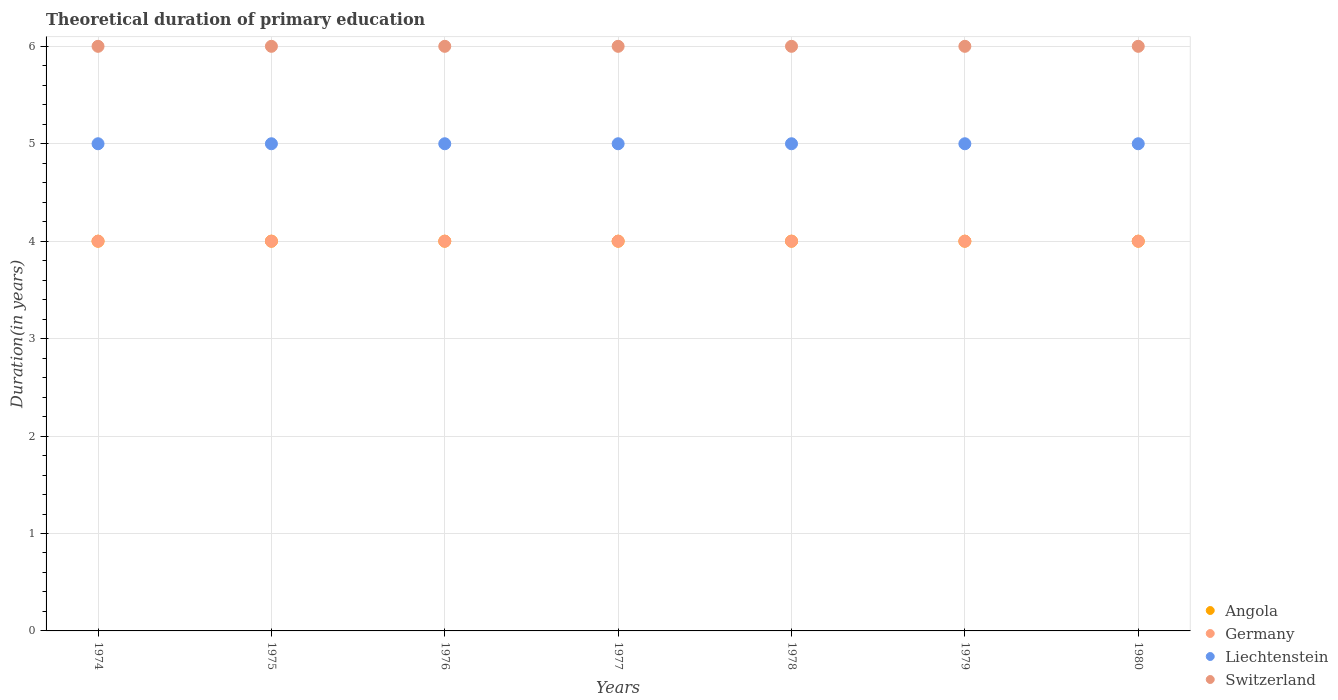Across all years, what is the maximum total theoretical duration of primary education in Liechtenstein?
Offer a very short reply. 5. Across all years, what is the minimum total theoretical duration of primary education in Switzerland?
Your response must be concise. 6. In which year was the total theoretical duration of primary education in Liechtenstein maximum?
Offer a very short reply. 1974. In which year was the total theoretical duration of primary education in Angola minimum?
Your response must be concise. 1974. What is the total total theoretical duration of primary education in Liechtenstein in the graph?
Offer a very short reply. 35. In the year 1974, what is the difference between the total theoretical duration of primary education in Germany and total theoretical duration of primary education in Liechtenstein?
Your answer should be compact. -1. What is the ratio of the total theoretical duration of primary education in Angola in 1976 to that in 1977?
Keep it short and to the point. 1. Is the total theoretical duration of primary education in Liechtenstein in 1977 less than that in 1979?
Offer a very short reply. No. Is the difference between the total theoretical duration of primary education in Germany in 1976 and 1979 greater than the difference between the total theoretical duration of primary education in Liechtenstein in 1976 and 1979?
Provide a succinct answer. No. What is the difference between the highest and the second highest total theoretical duration of primary education in Angola?
Give a very brief answer. 0. Is the sum of the total theoretical duration of primary education in Germany in 1975 and 1977 greater than the maximum total theoretical duration of primary education in Angola across all years?
Your answer should be very brief. Yes. Is it the case that in every year, the sum of the total theoretical duration of primary education in Germany and total theoretical duration of primary education in Angola  is greater than the sum of total theoretical duration of primary education in Liechtenstein and total theoretical duration of primary education in Switzerland?
Provide a short and direct response. No. Is it the case that in every year, the sum of the total theoretical duration of primary education in Angola and total theoretical duration of primary education in Switzerland  is greater than the total theoretical duration of primary education in Liechtenstein?
Your response must be concise. Yes. Is the total theoretical duration of primary education in Angola strictly greater than the total theoretical duration of primary education in Liechtenstein over the years?
Keep it short and to the point. No. How many years are there in the graph?
Provide a succinct answer. 7. What is the difference between two consecutive major ticks on the Y-axis?
Provide a succinct answer. 1. Are the values on the major ticks of Y-axis written in scientific E-notation?
Provide a succinct answer. No. Where does the legend appear in the graph?
Your answer should be compact. Bottom right. How many legend labels are there?
Offer a very short reply. 4. How are the legend labels stacked?
Keep it short and to the point. Vertical. What is the title of the graph?
Keep it short and to the point. Theoretical duration of primary education. What is the label or title of the Y-axis?
Give a very brief answer. Duration(in years). What is the Duration(in years) in Angola in 1974?
Ensure brevity in your answer.  4. What is the Duration(in years) of Germany in 1974?
Offer a terse response. 4. What is the Duration(in years) in Liechtenstein in 1974?
Your answer should be compact. 5. What is the Duration(in years) of Switzerland in 1974?
Your answer should be very brief. 6. What is the Duration(in years) of Germany in 1975?
Your response must be concise. 4. What is the Duration(in years) of Liechtenstein in 1975?
Your answer should be very brief. 5. What is the Duration(in years) in Switzerland in 1975?
Provide a short and direct response. 6. What is the Duration(in years) in Germany in 1976?
Provide a short and direct response. 4. What is the Duration(in years) in Switzerland in 1976?
Keep it short and to the point. 6. What is the Duration(in years) of Angola in 1977?
Your answer should be compact. 4. What is the Duration(in years) in Germany in 1977?
Your answer should be compact. 4. What is the Duration(in years) of Liechtenstein in 1977?
Keep it short and to the point. 5. What is the Duration(in years) in Angola in 1978?
Give a very brief answer. 4. What is the Duration(in years) in Switzerland in 1978?
Your answer should be compact. 6. What is the Duration(in years) in Switzerland in 1980?
Make the answer very short. 6. Across all years, what is the maximum Duration(in years) of Angola?
Your answer should be compact. 4. Across all years, what is the maximum Duration(in years) in Liechtenstein?
Offer a very short reply. 5. Across all years, what is the maximum Duration(in years) in Switzerland?
Keep it short and to the point. 6. Across all years, what is the minimum Duration(in years) of Angola?
Your answer should be compact. 4. Across all years, what is the minimum Duration(in years) in Switzerland?
Provide a short and direct response. 6. What is the total Duration(in years) of Angola in the graph?
Provide a succinct answer. 28. What is the total Duration(in years) of Liechtenstein in the graph?
Make the answer very short. 35. What is the difference between the Duration(in years) in Switzerland in 1974 and that in 1975?
Your answer should be compact. 0. What is the difference between the Duration(in years) of Liechtenstein in 1974 and that in 1976?
Keep it short and to the point. 0. What is the difference between the Duration(in years) in Angola in 1974 and that in 1978?
Offer a very short reply. 0. What is the difference between the Duration(in years) in Germany in 1974 and that in 1978?
Your answer should be very brief. 0. What is the difference between the Duration(in years) of Liechtenstein in 1974 and that in 1978?
Provide a short and direct response. 0. What is the difference between the Duration(in years) of Switzerland in 1974 and that in 1978?
Your answer should be very brief. 0. What is the difference between the Duration(in years) in Angola in 1974 and that in 1979?
Your answer should be very brief. 0. What is the difference between the Duration(in years) of Germany in 1974 and that in 1980?
Provide a short and direct response. 0. What is the difference between the Duration(in years) of Liechtenstein in 1974 and that in 1980?
Keep it short and to the point. 0. What is the difference between the Duration(in years) in Switzerland in 1974 and that in 1980?
Your answer should be very brief. 0. What is the difference between the Duration(in years) in Liechtenstein in 1975 and that in 1976?
Give a very brief answer. 0. What is the difference between the Duration(in years) of Switzerland in 1975 and that in 1976?
Your answer should be compact. 0. What is the difference between the Duration(in years) of Switzerland in 1975 and that in 1977?
Offer a very short reply. 0. What is the difference between the Duration(in years) of Angola in 1975 and that in 1978?
Offer a terse response. 0. What is the difference between the Duration(in years) in Germany in 1975 and that in 1979?
Offer a very short reply. 0. What is the difference between the Duration(in years) in Angola in 1975 and that in 1980?
Offer a very short reply. 0. What is the difference between the Duration(in years) of Germany in 1975 and that in 1980?
Your response must be concise. 0. What is the difference between the Duration(in years) of Switzerland in 1975 and that in 1980?
Provide a succinct answer. 0. What is the difference between the Duration(in years) in Germany in 1976 and that in 1977?
Offer a terse response. 0. What is the difference between the Duration(in years) in Liechtenstein in 1976 and that in 1977?
Make the answer very short. 0. What is the difference between the Duration(in years) of Angola in 1976 and that in 1978?
Provide a short and direct response. 0. What is the difference between the Duration(in years) of Germany in 1976 and that in 1978?
Keep it short and to the point. 0. What is the difference between the Duration(in years) in Liechtenstein in 1976 and that in 1978?
Your answer should be very brief. 0. What is the difference between the Duration(in years) in Switzerland in 1976 and that in 1978?
Your answer should be very brief. 0. What is the difference between the Duration(in years) of Angola in 1976 and that in 1979?
Your answer should be very brief. 0. What is the difference between the Duration(in years) of Germany in 1976 and that in 1979?
Offer a very short reply. 0. What is the difference between the Duration(in years) of Liechtenstein in 1976 and that in 1979?
Offer a terse response. 0. What is the difference between the Duration(in years) of Switzerland in 1976 and that in 1979?
Keep it short and to the point. 0. What is the difference between the Duration(in years) in Angola in 1977 and that in 1978?
Provide a short and direct response. 0. What is the difference between the Duration(in years) of Germany in 1977 and that in 1978?
Provide a short and direct response. 0. What is the difference between the Duration(in years) in Liechtenstein in 1977 and that in 1978?
Give a very brief answer. 0. What is the difference between the Duration(in years) in Switzerland in 1977 and that in 1978?
Your answer should be compact. 0. What is the difference between the Duration(in years) in Angola in 1977 and that in 1979?
Provide a short and direct response. 0. What is the difference between the Duration(in years) of Germany in 1977 and that in 1979?
Give a very brief answer. 0. What is the difference between the Duration(in years) of Liechtenstein in 1977 and that in 1979?
Make the answer very short. 0. What is the difference between the Duration(in years) of Switzerland in 1977 and that in 1979?
Your answer should be very brief. 0. What is the difference between the Duration(in years) of Switzerland in 1977 and that in 1980?
Make the answer very short. 0. What is the difference between the Duration(in years) in Germany in 1978 and that in 1979?
Provide a short and direct response. 0. What is the difference between the Duration(in years) of Switzerland in 1978 and that in 1979?
Your response must be concise. 0. What is the difference between the Duration(in years) in Germany in 1978 and that in 1980?
Keep it short and to the point. 0. What is the difference between the Duration(in years) in Liechtenstein in 1978 and that in 1980?
Ensure brevity in your answer.  0. What is the difference between the Duration(in years) in Angola in 1979 and that in 1980?
Your answer should be very brief. 0. What is the difference between the Duration(in years) of Liechtenstein in 1979 and that in 1980?
Provide a short and direct response. 0. What is the difference between the Duration(in years) in Angola in 1974 and the Duration(in years) in Switzerland in 1975?
Ensure brevity in your answer.  -2. What is the difference between the Duration(in years) of Angola in 1974 and the Duration(in years) of Germany in 1976?
Your response must be concise. 0. What is the difference between the Duration(in years) in Angola in 1974 and the Duration(in years) in Liechtenstein in 1976?
Ensure brevity in your answer.  -1. What is the difference between the Duration(in years) in Germany in 1974 and the Duration(in years) in Liechtenstein in 1976?
Keep it short and to the point. -1. What is the difference between the Duration(in years) in Germany in 1974 and the Duration(in years) in Switzerland in 1976?
Your answer should be compact. -2. What is the difference between the Duration(in years) of Angola in 1974 and the Duration(in years) of Germany in 1977?
Keep it short and to the point. 0. What is the difference between the Duration(in years) in Angola in 1974 and the Duration(in years) in Liechtenstein in 1977?
Provide a succinct answer. -1. What is the difference between the Duration(in years) of Germany in 1974 and the Duration(in years) of Liechtenstein in 1977?
Offer a terse response. -1. What is the difference between the Duration(in years) of Germany in 1974 and the Duration(in years) of Switzerland in 1977?
Offer a very short reply. -2. What is the difference between the Duration(in years) in Angola in 1974 and the Duration(in years) in Germany in 1978?
Provide a succinct answer. 0. What is the difference between the Duration(in years) in Germany in 1974 and the Duration(in years) in Liechtenstein in 1978?
Offer a terse response. -1. What is the difference between the Duration(in years) of Liechtenstein in 1974 and the Duration(in years) of Switzerland in 1978?
Ensure brevity in your answer.  -1. What is the difference between the Duration(in years) of Angola in 1974 and the Duration(in years) of Liechtenstein in 1979?
Offer a very short reply. -1. What is the difference between the Duration(in years) of Germany in 1974 and the Duration(in years) of Liechtenstein in 1979?
Offer a very short reply. -1. What is the difference between the Duration(in years) of Germany in 1974 and the Duration(in years) of Switzerland in 1979?
Make the answer very short. -2. What is the difference between the Duration(in years) of Angola in 1974 and the Duration(in years) of Germany in 1980?
Make the answer very short. 0. What is the difference between the Duration(in years) of Germany in 1974 and the Duration(in years) of Switzerland in 1980?
Make the answer very short. -2. What is the difference between the Duration(in years) in Angola in 1975 and the Duration(in years) in Switzerland in 1976?
Make the answer very short. -2. What is the difference between the Duration(in years) in Germany in 1975 and the Duration(in years) in Liechtenstein in 1976?
Provide a short and direct response. -1. What is the difference between the Duration(in years) of Germany in 1975 and the Duration(in years) of Switzerland in 1976?
Your response must be concise. -2. What is the difference between the Duration(in years) of Angola in 1975 and the Duration(in years) of Liechtenstein in 1977?
Ensure brevity in your answer.  -1. What is the difference between the Duration(in years) in Angola in 1975 and the Duration(in years) in Switzerland in 1977?
Your response must be concise. -2. What is the difference between the Duration(in years) in Germany in 1975 and the Duration(in years) in Liechtenstein in 1977?
Your answer should be very brief. -1. What is the difference between the Duration(in years) in Angola in 1975 and the Duration(in years) in Switzerland in 1978?
Your answer should be very brief. -2. What is the difference between the Duration(in years) in Germany in 1975 and the Duration(in years) in Liechtenstein in 1978?
Your response must be concise. -1. What is the difference between the Duration(in years) in Liechtenstein in 1975 and the Duration(in years) in Switzerland in 1978?
Give a very brief answer. -1. What is the difference between the Duration(in years) of Angola in 1975 and the Duration(in years) of Germany in 1979?
Offer a terse response. 0. What is the difference between the Duration(in years) in Angola in 1975 and the Duration(in years) in Liechtenstein in 1979?
Provide a short and direct response. -1. What is the difference between the Duration(in years) in Angola in 1975 and the Duration(in years) in Switzerland in 1979?
Offer a very short reply. -2. What is the difference between the Duration(in years) of Germany in 1975 and the Duration(in years) of Switzerland in 1979?
Offer a terse response. -2. What is the difference between the Duration(in years) in Angola in 1975 and the Duration(in years) in Germany in 1980?
Keep it short and to the point. 0. What is the difference between the Duration(in years) in Angola in 1975 and the Duration(in years) in Switzerland in 1980?
Offer a terse response. -2. What is the difference between the Duration(in years) of Liechtenstein in 1975 and the Duration(in years) of Switzerland in 1980?
Keep it short and to the point. -1. What is the difference between the Duration(in years) in Angola in 1976 and the Duration(in years) in Switzerland in 1977?
Keep it short and to the point. -2. What is the difference between the Duration(in years) of Germany in 1976 and the Duration(in years) of Liechtenstein in 1977?
Provide a succinct answer. -1. What is the difference between the Duration(in years) of Angola in 1976 and the Duration(in years) of Liechtenstein in 1978?
Offer a terse response. -1. What is the difference between the Duration(in years) in Germany in 1976 and the Duration(in years) in Switzerland in 1978?
Provide a short and direct response. -2. What is the difference between the Duration(in years) in Liechtenstein in 1976 and the Duration(in years) in Switzerland in 1978?
Your answer should be very brief. -1. What is the difference between the Duration(in years) of Angola in 1976 and the Duration(in years) of Germany in 1979?
Keep it short and to the point. 0. What is the difference between the Duration(in years) in Angola in 1976 and the Duration(in years) in Liechtenstein in 1979?
Provide a short and direct response. -1. What is the difference between the Duration(in years) in Germany in 1976 and the Duration(in years) in Liechtenstein in 1979?
Provide a short and direct response. -1. What is the difference between the Duration(in years) in Germany in 1976 and the Duration(in years) in Switzerland in 1979?
Your answer should be compact. -2. What is the difference between the Duration(in years) in Angola in 1976 and the Duration(in years) in Liechtenstein in 1980?
Give a very brief answer. -1. What is the difference between the Duration(in years) in Germany in 1976 and the Duration(in years) in Switzerland in 1980?
Offer a terse response. -2. What is the difference between the Duration(in years) in Angola in 1977 and the Duration(in years) in Switzerland in 1978?
Ensure brevity in your answer.  -2. What is the difference between the Duration(in years) of Germany in 1977 and the Duration(in years) of Liechtenstein in 1978?
Your answer should be compact. -1. What is the difference between the Duration(in years) of Germany in 1977 and the Duration(in years) of Switzerland in 1978?
Provide a short and direct response. -2. What is the difference between the Duration(in years) of Angola in 1977 and the Duration(in years) of Liechtenstein in 1979?
Your answer should be compact. -1. What is the difference between the Duration(in years) of Germany in 1977 and the Duration(in years) of Liechtenstein in 1979?
Keep it short and to the point. -1. What is the difference between the Duration(in years) in Liechtenstein in 1977 and the Duration(in years) in Switzerland in 1979?
Your answer should be compact. -1. What is the difference between the Duration(in years) of Angola in 1978 and the Duration(in years) of Liechtenstein in 1979?
Offer a very short reply. -1. What is the difference between the Duration(in years) in Angola in 1978 and the Duration(in years) in Switzerland in 1979?
Give a very brief answer. -2. What is the difference between the Duration(in years) of Germany in 1978 and the Duration(in years) of Liechtenstein in 1979?
Make the answer very short. -1. What is the difference between the Duration(in years) of Liechtenstein in 1978 and the Duration(in years) of Switzerland in 1979?
Ensure brevity in your answer.  -1. What is the difference between the Duration(in years) of Angola in 1978 and the Duration(in years) of Switzerland in 1980?
Offer a very short reply. -2. What is the difference between the Duration(in years) of Germany in 1978 and the Duration(in years) of Liechtenstein in 1980?
Offer a very short reply. -1. What is the difference between the Duration(in years) in Germany in 1978 and the Duration(in years) in Switzerland in 1980?
Offer a terse response. -2. What is the difference between the Duration(in years) in Angola in 1979 and the Duration(in years) in Germany in 1980?
Provide a short and direct response. 0. What is the difference between the Duration(in years) in Angola in 1979 and the Duration(in years) in Liechtenstein in 1980?
Provide a succinct answer. -1. What is the difference between the Duration(in years) in Germany in 1979 and the Duration(in years) in Switzerland in 1980?
Provide a short and direct response. -2. What is the difference between the Duration(in years) in Liechtenstein in 1979 and the Duration(in years) in Switzerland in 1980?
Keep it short and to the point. -1. What is the average Duration(in years) of Germany per year?
Provide a succinct answer. 4. What is the average Duration(in years) in Switzerland per year?
Make the answer very short. 6. In the year 1974, what is the difference between the Duration(in years) of Angola and Duration(in years) of Liechtenstein?
Offer a terse response. -1. In the year 1974, what is the difference between the Duration(in years) of Germany and Duration(in years) of Liechtenstein?
Offer a terse response. -1. In the year 1974, what is the difference between the Duration(in years) in Germany and Duration(in years) in Switzerland?
Make the answer very short. -2. In the year 1974, what is the difference between the Duration(in years) in Liechtenstein and Duration(in years) in Switzerland?
Offer a very short reply. -1. In the year 1975, what is the difference between the Duration(in years) of Angola and Duration(in years) of Germany?
Ensure brevity in your answer.  0. In the year 1975, what is the difference between the Duration(in years) in Germany and Duration(in years) in Liechtenstein?
Give a very brief answer. -1. In the year 1975, what is the difference between the Duration(in years) in Germany and Duration(in years) in Switzerland?
Ensure brevity in your answer.  -2. In the year 1976, what is the difference between the Duration(in years) of Angola and Duration(in years) of Liechtenstein?
Provide a short and direct response. -1. In the year 1976, what is the difference between the Duration(in years) of Germany and Duration(in years) of Switzerland?
Provide a short and direct response. -2. In the year 1976, what is the difference between the Duration(in years) in Liechtenstein and Duration(in years) in Switzerland?
Offer a terse response. -1. In the year 1977, what is the difference between the Duration(in years) in Germany and Duration(in years) in Liechtenstein?
Your response must be concise. -1. In the year 1978, what is the difference between the Duration(in years) of Angola and Duration(in years) of Liechtenstein?
Provide a succinct answer. -1. In the year 1978, what is the difference between the Duration(in years) in Germany and Duration(in years) in Liechtenstein?
Your answer should be compact. -1. In the year 1978, what is the difference between the Duration(in years) of Liechtenstein and Duration(in years) of Switzerland?
Offer a very short reply. -1. In the year 1979, what is the difference between the Duration(in years) of Angola and Duration(in years) of Germany?
Keep it short and to the point. 0. In the year 1979, what is the difference between the Duration(in years) in Angola and Duration(in years) in Liechtenstein?
Your answer should be compact. -1. In the year 1979, what is the difference between the Duration(in years) in Liechtenstein and Duration(in years) in Switzerland?
Give a very brief answer. -1. In the year 1980, what is the difference between the Duration(in years) of Angola and Duration(in years) of Germany?
Your answer should be very brief. 0. In the year 1980, what is the difference between the Duration(in years) of Angola and Duration(in years) of Liechtenstein?
Keep it short and to the point. -1. In the year 1980, what is the difference between the Duration(in years) in Angola and Duration(in years) in Switzerland?
Provide a succinct answer. -2. What is the ratio of the Duration(in years) of Angola in 1974 to that in 1975?
Provide a short and direct response. 1. What is the ratio of the Duration(in years) of Germany in 1974 to that in 1975?
Provide a short and direct response. 1. What is the ratio of the Duration(in years) of Switzerland in 1974 to that in 1975?
Keep it short and to the point. 1. What is the ratio of the Duration(in years) of Angola in 1974 to that in 1976?
Your response must be concise. 1. What is the ratio of the Duration(in years) in Liechtenstein in 1974 to that in 1976?
Provide a short and direct response. 1. What is the ratio of the Duration(in years) of Switzerland in 1974 to that in 1976?
Offer a terse response. 1. What is the ratio of the Duration(in years) in Liechtenstein in 1974 to that in 1977?
Keep it short and to the point. 1. What is the ratio of the Duration(in years) in Switzerland in 1974 to that in 1977?
Offer a terse response. 1. What is the ratio of the Duration(in years) of Germany in 1974 to that in 1978?
Your answer should be compact. 1. What is the ratio of the Duration(in years) in Liechtenstein in 1974 to that in 1978?
Make the answer very short. 1. What is the ratio of the Duration(in years) of Switzerland in 1974 to that in 1978?
Keep it short and to the point. 1. What is the ratio of the Duration(in years) of Germany in 1974 to that in 1979?
Your answer should be compact. 1. What is the ratio of the Duration(in years) of Liechtenstein in 1974 to that in 1979?
Provide a short and direct response. 1. What is the ratio of the Duration(in years) in Germany in 1974 to that in 1980?
Offer a very short reply. 1. What is the ratio of the Duration(in years) in Liechtenstein in 1974 to that in 1980?
Make the answer very short. 1. What is the ratio of the Duration(in years) of Angola in 1975 to that in 1976?
Keep it short and to the point. 1. What is the ratio of the Duration(in years) in Liechtenstein in 1975 to that in 1976?
Your answer should be very brief. 1. What is the ratio of the Duration(in years) in Angola in 1975 to that in 1977?
Offer a very short reply. 1. What is the ratio of the Duration(in years) in Liechtenstein in 1975 to that in 1977?
Provide a succinct answer. 1. What is the ratio of the Duration(in years) in Angola in 1975 to that in 1978?
Ensure brevity in your answer.  1. What is the ratio of the Duration(in years) in Liechtenstein in 1975 to that in 1978?
Your answer should be compact. 1. What is the ratio of the Duration(in years) in Germany in 1975 to that in 1979?
Your answer should be compact. 1. What is the ratio of the Duration(in years) in Switzerland in 1975 to that in 1979?
Make the answer very short. 1. What is the ratio of the Duration(in years) in Germany in 1975 to that in 1980?
Give a very brief answer. 1. What is the ratio of the Duration(in years) of Switzerland in 1975 to that in 1980?
Your answer should be very brief. 1. What is the ratio of the Duration(in years) in Angola in 1976 to that in 1978?
Your answer should be very brief. 1. What is the ratio of the Duration(in years) of Angola in 1976 to that in 1979?
Your response must be concise. 1. What is the ratio of the Duration(in years) in Germany in 1976 to that in 1979?
Your answer should be very brief. 1. What is the ratio of the Duration(in years) of Switzerland in 1976 to that in 1979?
Provide a short and direct response. 1. What is the ratio of the Duration(in years) in Angola in 1976 to that in 1980?
Offer a very short reply. 1. What is the ratio of the Duration(in years) in Liechtenstein in 1976 to that in 1980?
Your answer should be very brief. 1. What is the ratio of the Duration(in years) of Switzerland in 1976 to that in 1980?
Offer a terse response. 1. What is the ratio of the Duration(in years) in Germany in 1977 to that in 1978?
Offer a very short reply. 1. What is the ratio of the Duration(in years) in Switzerland in 1977 to that in 1979?
Your answer should be very brief. 1. What is the ratio of the Duration(in years) in Angola in 1978 to that in 1979?
Your response must be concise. 1. What is the ratio of the Duration(in years) in Liechtenstein in 1978 to that in 1979?
Your answer should be very brief. 1. What is the ratio of the Duration(in years) in Angola in 1978 to that in 1980?
Your answer should be compact. 1. What is the ratio of the Duration(in years) in Switzerland in 1978 to that in 1980?
Make the answer very short. 1. What is the ratio of the Duration(in years) of Germany in 1979 to that in 1980?
Your answer should be compact. 1. What is the ratio of the Duration(in years) of Liechtenstein in 1979 to that in 1980?
Offer a very short reply. 1. What is the ratio of the Duration(in years) in Switzerland in 1979 to that in 1980?
Ensure brevity in your answer.  1. What is the difference between the highest and the second highest Duration(in years) in Germany?
Give a very brief answer. 0. What is the difference between the highest and the second highest Duration(in years) in Liechtenstein?
Ensure brevity in your answer.  0. What is the difference between the highest and the second highest Duration(in years) of Switzerland?
Give a very brief answer. 0. What is the difference between the highest and the lowest Duration(in years) of Germany?
Provide a short and direct response. 0. What is the difference between the highest and the lowest Duration(in years) of Switzerland?
Ensure brevity in your answer.  0. 